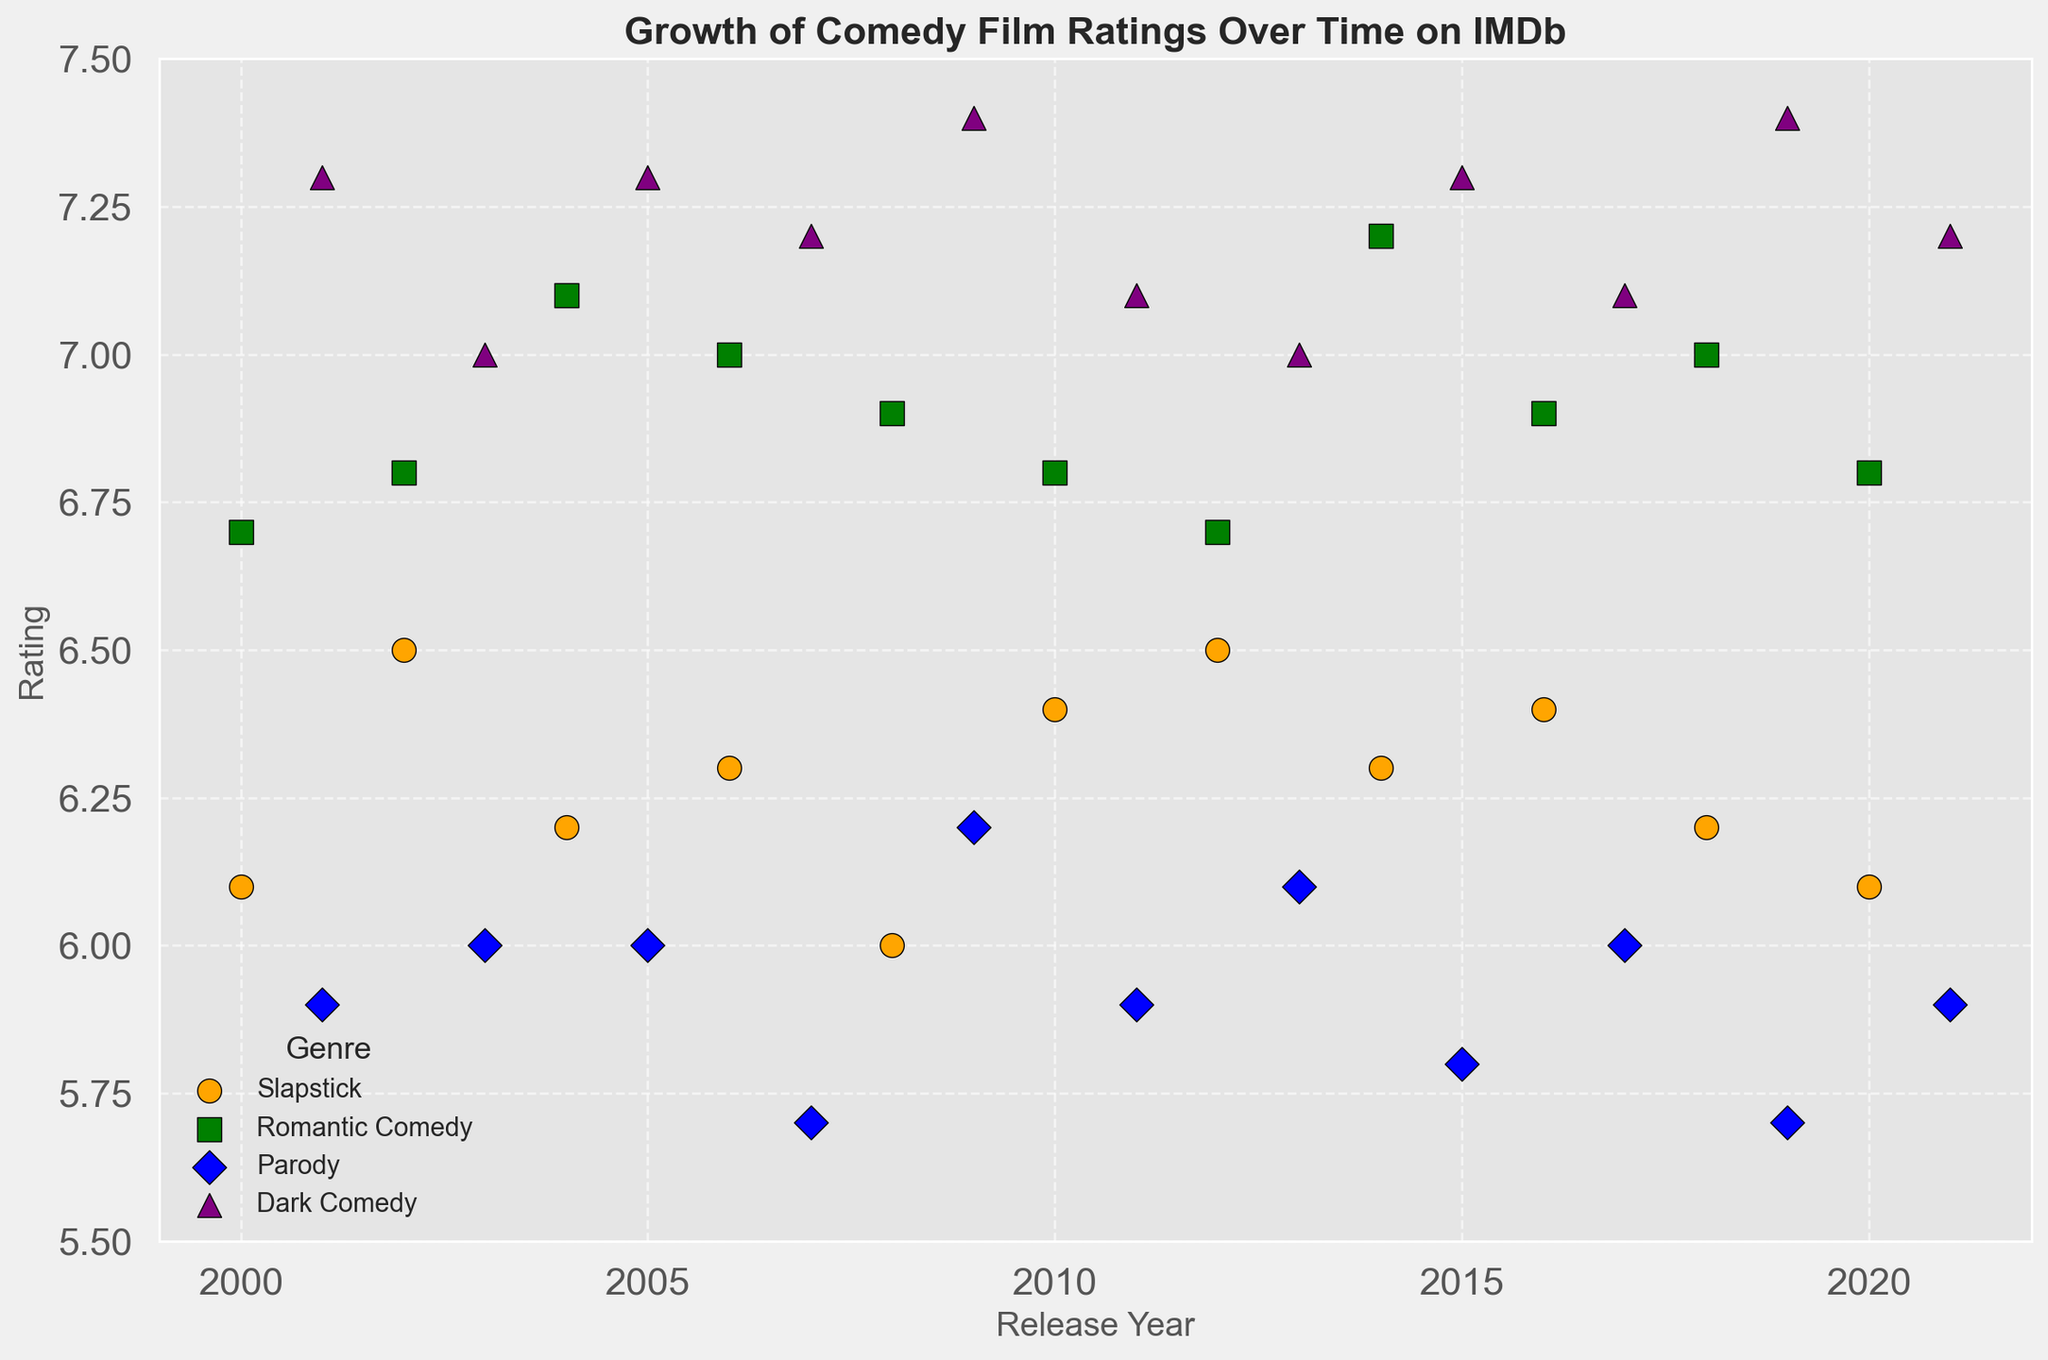Which genre has the highest average rating over the entire period? Dark Comedy has the most consistently high ratings over the years. Visually inspecting the scatter plot, the purple triangles (Dark Comedy) are generally higher than the other genres.
Answer: Dark Comedy Between Slapstick and Romantic Comedy, which genre shows a more noticeable increase in ratings between 2001 and 2002? By comparing the orange circles (Slapstick) and green squares (Romantic Comedy) between 2001 and 2002, Romantic Comedy shows a slight increase, while Slapstick also shows a slight rise, but not as noticeable.
Answer: Romantic Comedy What is the trend in ratings for Parody films from 2000 to 2005? Looking at the blue diamonds (Parody) in the scatter plot from 2000 to 2005, there is a slight initial drop from 5.9 in 2001, a small increase to 6.0 in 2003, maintaining the same till 2005.
Answer: Slightly fluctuating with no clear upward or downward trend Which genre has the most varied ratings over the years? By visually inspecting the scatter plot, one can observe that Parody (blue diamonds) exhibits the widest range of ratings across the years, with ratings as low as 5.7 and as high as 6.2.
Answer: Parody In what year does Dark Comedy have its highest rating, and what is that rating? Observing the purple triangles, Dark Comedy reaches its peak rating in 2009 and 2019, where the triangles are at their highest position.
Answer: 2009, 2019 and rating 7.4 Comparing the ratings of Romantic Comedy and Dark Comedy in 2018, which one is higher? In 2018, the green square (Romantic Comedy) is slightly lower than the purple triangle (Dark Comedy).
Answer: Dark Comedy What is the average rating of Slapstick films for the years shown? Adding up the ratings of Slapstick films: 6.1+6.5+6.2+6.3+6.0+6.4+6.1+6.5+6.3+6.4+6.2+6.1 and dividing by the number of years (12) gives an average. The calculation shows the sum is 75.2 and the average is 75.2/12, which approximately equals 6.27.
Answer: Approximately 6.27 Which genre shows the least change in ratings over the years? By visually inspecting the scatter plot, the green squares (Romantic Comedy) remain fairly stable, with minimal variation in their positions.
Answer: Romantic Comedy Between the years 2014 and 2015, which genre has a noticeably different rating trend? Comparing the genres, Parody in blue shows a decline from 6.1 to 5.8 between 2014 and 2015, compared to more stable ratings in other genres.
Answer: Parody From 2010 to 2012, which genre experienced a decrease in ratings? Visual inspection of the plot shows that Parody (blue diamonds) goes from 5.9 in 2011 to 5.8 in 2015, showing a decrease in rating
Answer: Parody 